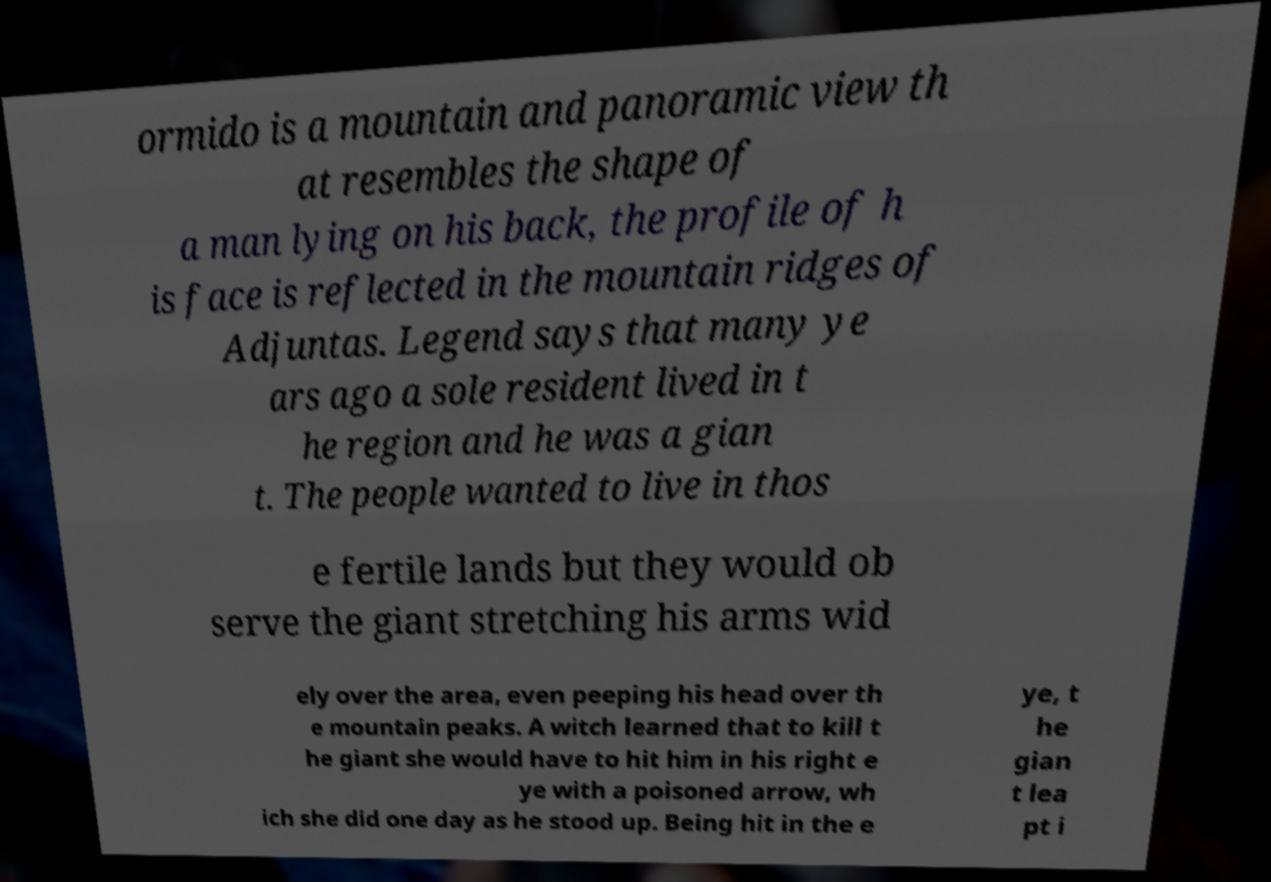Could you extract and type out the text from this image? ormido is a mountain and panoramic view th at resembles the shape of a man lying on his back, the profile of h is face is reflected in the mountain ridges of Adjuntas. Legend says that many ye ars ago a sole resident lived in t he region and he was a gian t. The people wanted to live in thos e fertile lands but they would ob serve the giant stretching his arms wid ely over the area, even peeping his head over th e mountain peaks. A witch learned that to kill t he giant she would have to hit him in his right e ye with a poisoned arrow, wh ich she did one day as he stood up. Being hit in the e ye, t he gian t lea pt i 